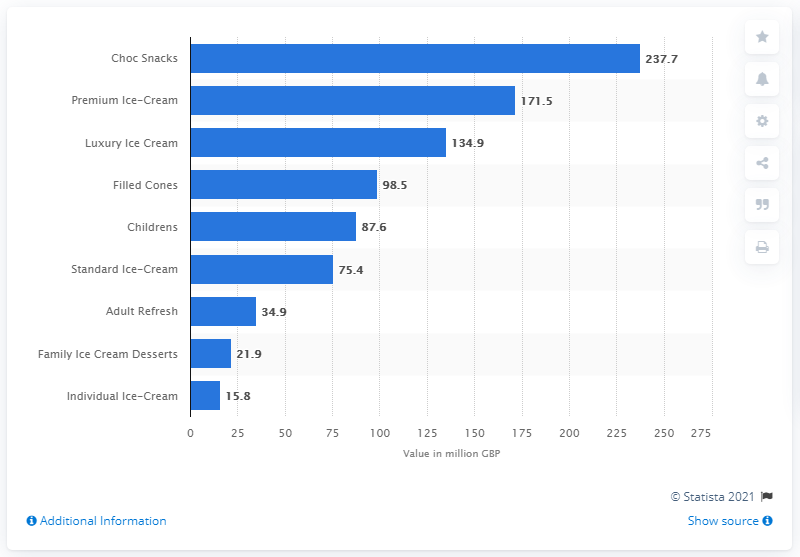Give some essential details in this illustration. The market value of premium ice cream for the 52 weeks ending November 8, 2015, was 171.5 dollars. 